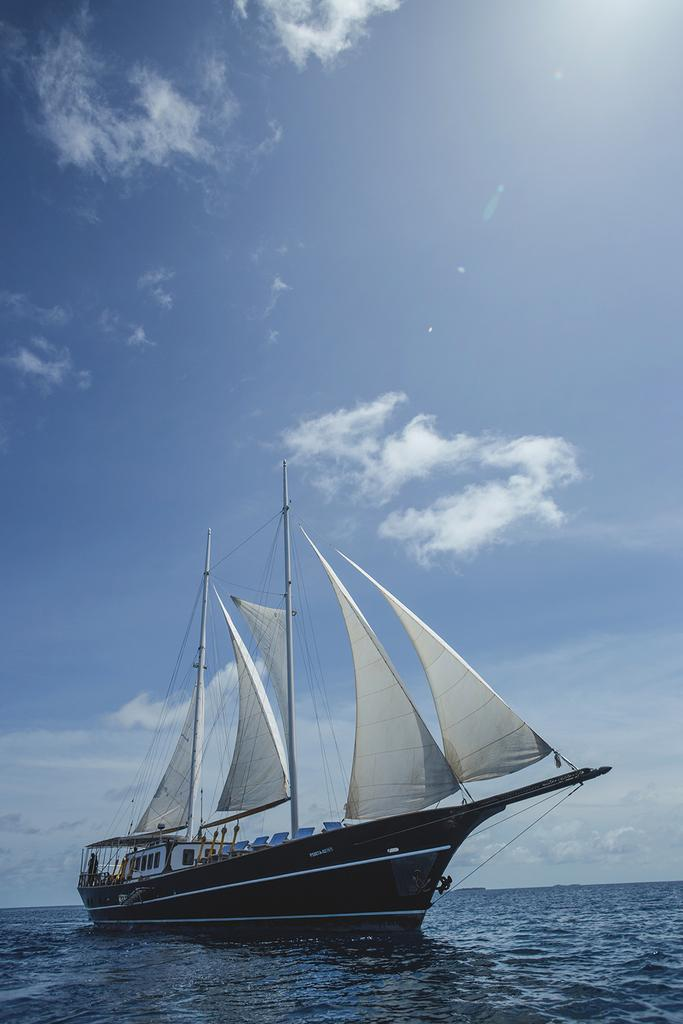What is the main subject of the image? The main subject of the image is a boat. Where is the boat located in the image? The boat is on the water in the image. What features can be seen on the boat? The boat has poles and sails visible, as well as other objects. How would you describe the sky in the image? The sky is blue and cloudy in the image. What type of canvas is being used to paint the boat in the image? There is no indication in the image that the boat is being painted, nor is there any canvas present. 